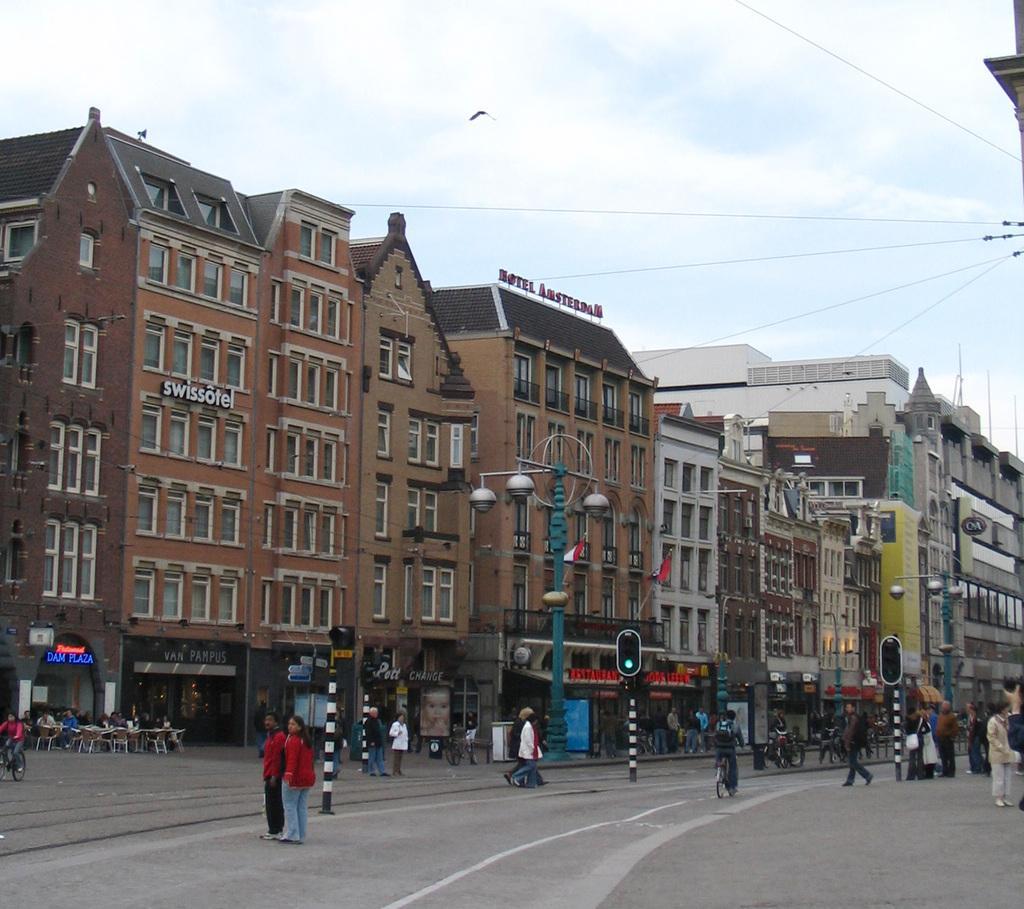In one or two sentences, can you explain what this image depicts? In this image I can see buildings, people, traffic lights and poles. I can also see a person sitting on a bicycle, people sitting on chairs, a bird is flying in the air and the sky in the background. 